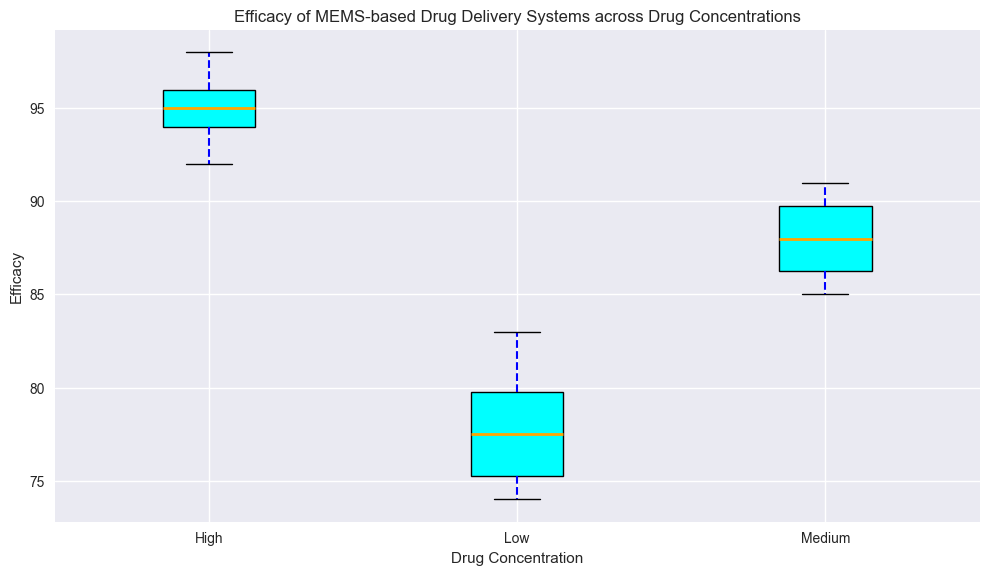What is the median efficacy for the Low drug concentration group? The median is the middle value of the sorted list. For the Low concentration group, the values are: 74, 74, 75, 76, 77, 78, 79, 80, 81, 83. The middle values are 77 and 78, so the median is the average of these two numbers: (77 + 78) / 2 = 77.5
Answer: 77.5 Which drug concentration group has the highest median efficacy? Observing the box plots, the median is represented by the orange line inside each box. The median for the High concentration group is highest compared to the Low and Medium groups.
Answer: High Is the spread of efficacy values larger for the Medium or High drug concentration group? The spread or interquartile range (IQR) is the distance between the 1st quartile (bottom of the box) and the 3rd quartile (top of the box). The High concentration group has a smaller box height compared to the Medium group, indicating a smaller spread.
Answer: Medium What is the range of the efficacy values for the Low drug concentration group? The range is the difference between the maximum and minimum values. For the Low concentration group, the minimum is 74 and the maximum is 83. So, the range is 83 - 74 = 9
Answer: 9 Are there any outliers in the High drug concentration group? Outliers are typically marked by distinct points beyond the whiskers in a box plot. The High concentration group does not have any marked red points, indicating no outliers.
Answer: No Between which two groups is the biggest difference in median efficacy observed? The biggest difference in median efficacy can be observed by comparing the orange lines in the boxes. There is the largest gap between the median efficacy of the Low and High concentration groups.
Answer: Low and High How does the upper boundary of the interquartile range for the Medium concentration compare to the lower boundary of the interquartile range for the High concentration? The upper boundary of the IQR for the Medium group is around 90. The lower boundary for the High concentration is around 94. Thus, the lower boundary of the High group is higher than the upper boundary of the Medium group.
Answer: Higher What is the interquartile range (IQR) for the Low drug concentration group? The IQR is the range between the 3rd quartile (top of the box) and the 1st quartile (bottom of the box). For the Low concentration group, this range is approximately 80 - 75 = 5
Answer: 5 